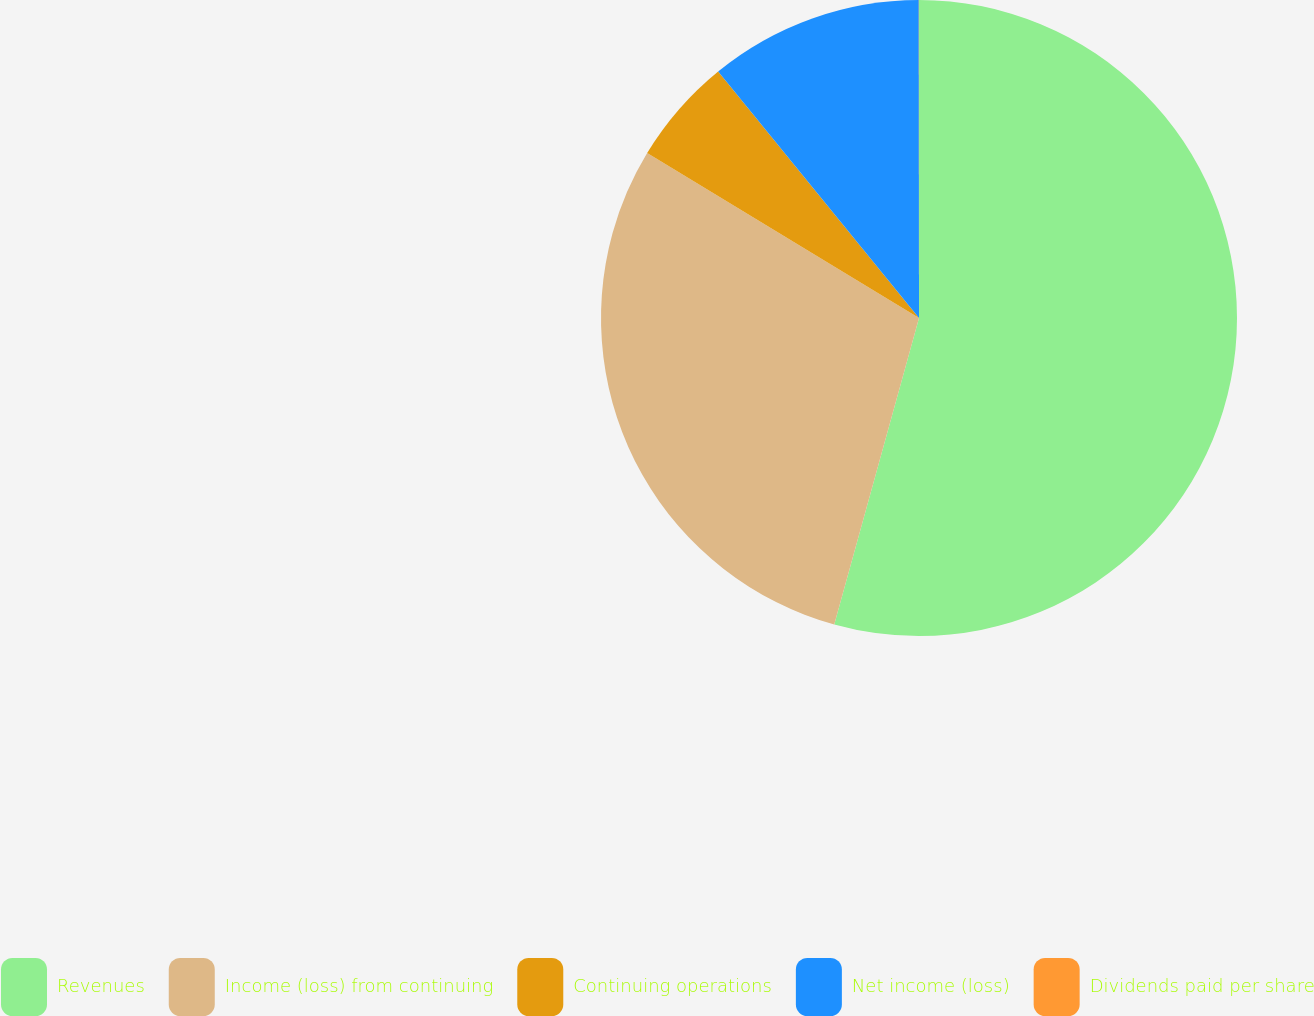Convert chart. <chart><loc_0><loc_0><loc_500><loc_500><pie_chart><fcel>Revenues<fcel>Income (loss) from continuing<fcel>Continuing operations<fcel>Net income (loss)<fcel>Dividends paid per share<nl><fcel>54.3%<fcel>29.39%<fcel>5.44%<fcel>10.87%<fcel>0.01%<nl></chart> 